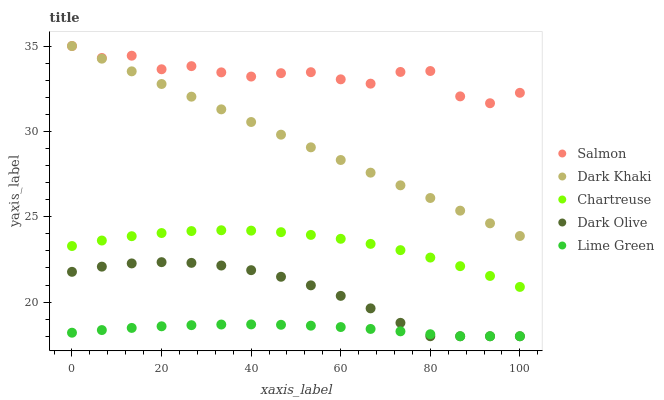Does Lime Green have the minimum area under the curve?
Answer yes or no. Yes. Does Salmon have the maximum area under the curve?
Answer yes or no. Yes. Does Chartreuse have the minimum area under the curve?
Answer yes or no. No. Does Chartreuse have the maximum area under the curve?
Answer yes or no. No. Is Dark Khaki the smoothest?
Answer yes or no. Yes. Is Salmon the roughest?
Answer yes or no. Yes. Is Lime Green the smoothest?
Answer yes or no. No. Is Lime Green the roughest?
Answer yes or no. No. Does Lime Green have the lowest value?
Answer yes or no. Yes. Does Chartreuse have the lowest value?
Answer yes or no. No. Does Salmon have the highest value?
Answer yes or no. Yes. Does Chartreuse have the highest value?
Answer yes or no. No. Is Chartreuse less than Salmon?
Answer yes or no. Yes. Is Dark Khaki greater than Lime Green?
Answer yes or no. Yes. Does Dark Khaki intersect Salmon?
Answer yes or no. Yes. Is Dark Khaki less than Salmon?
Answer yes or no. No. Is Dark Khaki greater than Salmon?
Answer yes or no. No. Does Chartreuse intersect Salmon?
Answer yes or no. No. 